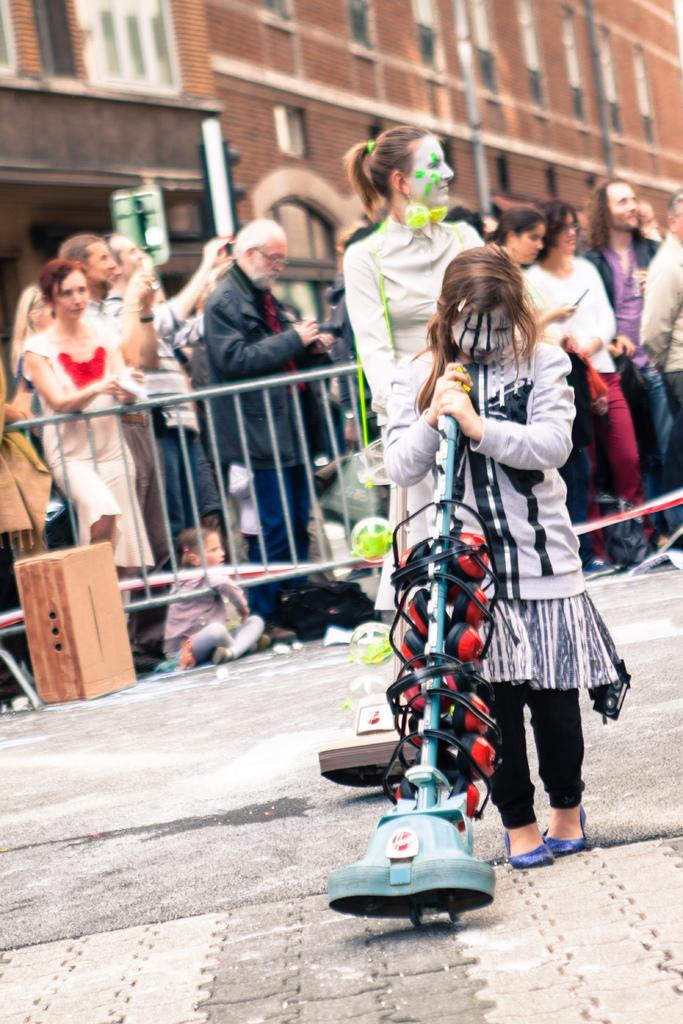Describe this image in one or two sentences. In this image I can see few people are standing. I can see most of them are wearing jackets. In the background I can see a building, number of windows and here I can see she is holding an equipment. 